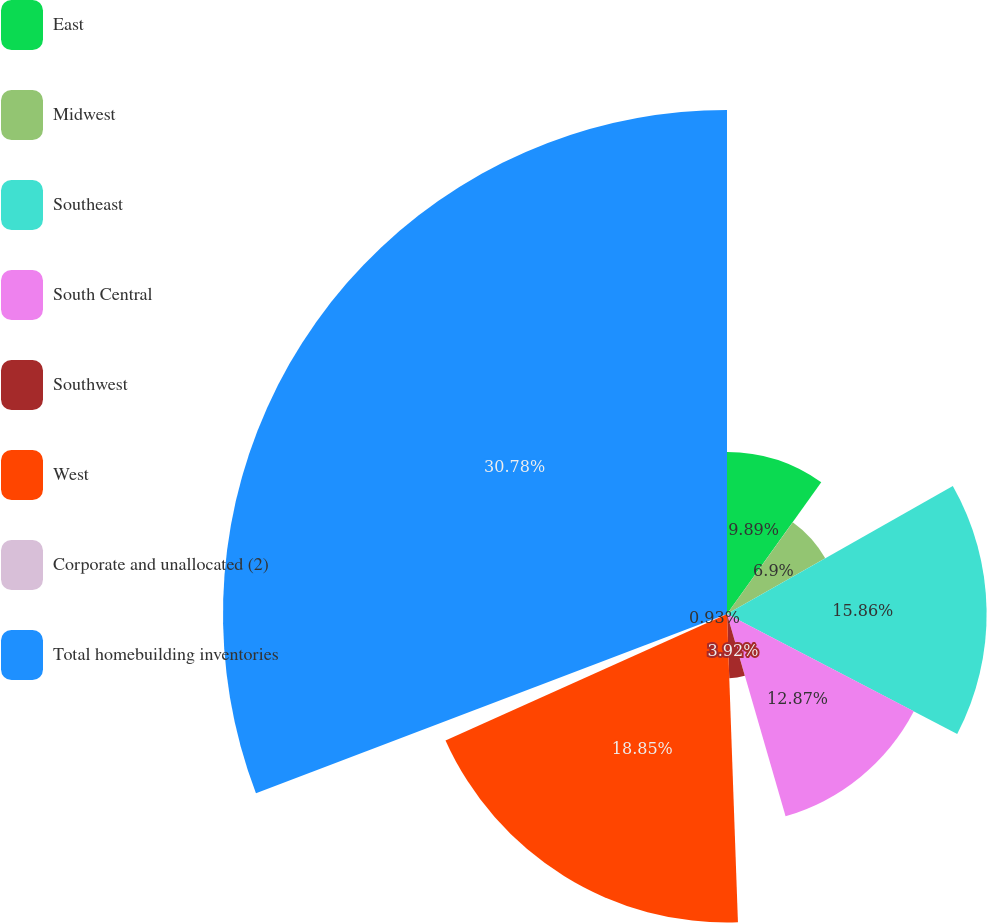Convert chart. <chart><loc_0><loc_0><loc_500><loc_500><pie_chart><fcel>East<fcel>Midwest<fcel>Southeast<fcel>South Central<fcel>Southwest<fcel>West<fcel>Corporate and unallocated (2)<fcel>Total homebuilding inventories<nl><fcel>9.89%<fcel>6.9%<fcel>15.86%<fcel>12.87%<fcel>3.92%<fcel>18.85%<fcel>0.93%<fcel>30.79%<nl></chart> 